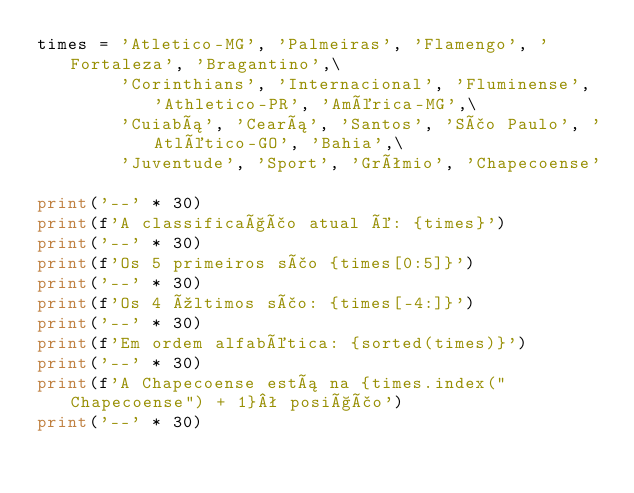<code> <loc_0><loc_0><loc_500><loc_500><_Python_>times = 'Atletico-MG', 'Palmeiras', 'Flamengo', 'Fortaleza', 'Bragantino',\
        'Corinthians', 'Internacional', 'Fluminense', 'Athletico-PR', 'América-MG',\
        'Cuiabá', 'Ceará', 'Santos', 'São Paulo', 'Atlético-GO', 'Bahia',\
        'Juventude', 'Sport', 'Grêmio', 'Chapecoense'

print('--' * 30)
print(f'A classificação atual é: {times}')
print('--' * 30)
print(f'Os 5 primeiros são {times[0:5]}')
print('--' * 30)
print(f'Os 4 últimos são: {times[-4:]}')
print('--' * 30)
print(f'Em ordem alfabética: {sorted(times)}')
print('--' * 30)
print(f'A Chapecoense está na {times.index("Chapecoense") + 1}ª posição')
print('--' * 30)</code> 